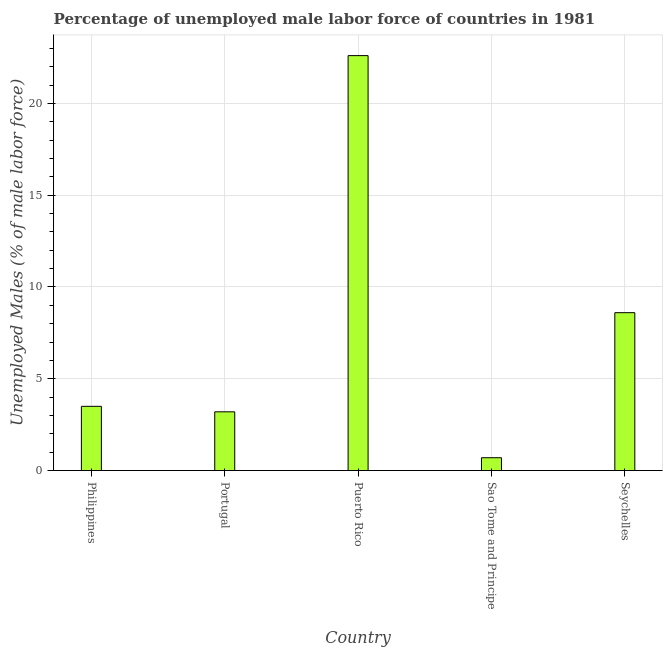Does the graph contain grids?
Keep it short and to the point. Yes. What is the title of the graph?
Offer a terse response. Percentage of unemployed male labor force of countries in 1981. What is the label or title of the X-axis?
Offer a terse response. Country. What is the label or title of the Y-axis?
Your answer should be very brief. Unemployed Males (% of male labor force). What is the total unemployed male labour force in Sao Tome and Principe?
Ensure brevity in your answer.  0.7. Across all countries, what is the maximum total unemployed male labour force?
Offer a very short reply. 22.6. Across all countries, what is the minimum total unemployed male labour force?
Provide a short and direct response. 0.7. In which country was the total unemployed male labour force maximum?
Provide a succinct answer. Puerto Rico. In which country was the total unemployed male labour force minimum?
Make the answer very short. Sao Tome and Principe. What is the sum of the total unemployed male labour force?
Offer a terse response. 38.6. What is the average total unemployed male labour force per country?
Keep it short and to the point. 7.72. What is the ratio of the total unemployed male labour force in Puerto Rico to that in Sao Tome and Principe?
Ensure brevity in your answer.  32.29. Is the difference between the total unemployed male labour force in Philippines and Sao Tome and Principe greater than the difference between any two countries?
Your response must be concise. No. Is the sum of the total unemployed male labour force in Puerto Rico and Seychelles greater than the maximum total unemployed male labour force across all countries?
Provide a succinct answer. Yes. What is the difference between the highest and the lowest total unemployed male labour force?
Make the answer very short. 21.9. Are the values on the major ticks of Y-axis written in scientific E-notation?
Offer a terse response. No. What is the Unemployed Males (% of male labor force) of Philippines?
Keep it short and to the point. 3.5. What is the Unemployed Males (% of male labor force) of Portugal?
Make the answer very short. 3.2. What is the Unemployed Males (% of male labor force) of Puerto Rico?
Give a very brief answer. 22.6. What is the Unemployed Males (% of male labor force) in Sao Tome and Principe?
Offer a terse response. 0.7. What is the Unemployed Males (% of male labor force) of Seychelles?
Ensure brevity in your answer.  8.6. What is the difference between the Unemployed Males (% of male labor force) in Philippines and Puerto Rico?
Your response must be concise. -19.1. What is the difference between the Unemployed Males (% of male labor force) in Philippines and Seychelles?
Provide a short and direct response. -5.1. What is the difference between the Unemployed Males (% of male labor force) in Portugal and Puerto Rico?
Your response must be concise. -19.4. What is the difference between the Unemployed Males (% of male labor force) in Puerto Rico and Sao Tome and Principe?
Give a very brief answer. 21.9. What is the difference between the Unemployed Males (% of male labor force) in Puerto Rico and Seychelles?
Your response must be concise. 14. What is the difference between the Unemployed Males (% of male labor force) in Sao Tome and Principe and Seychelles?
Provide a succinct answer. -7.9. What is the ratio of the Unemployed Males (% of male labor force) in Philippines to that in Portugal?
Your response must be concise. 1.09. What is the ratio of the Unemployed Males (% of male labor force) in Philippines to that in Puerto Rico?
Your answer should be very brief. 0.15. What is the ratio of the Unemployed Males (% of male labor force) in Philippines to that in Sao Tome and Principe?
Your answer should be very brief. 5. What is the ratio of the Unemployed Males (% of male labor force) in Philippines to that in Seychelles?
Make the answer very short. 0.41. What is the ratio of the Unemployed Males (% of male labor force) in Portugal to that in Puerto Rico?
Ensure brevity in your answer.  0.14. What is the ratio of the Unemployed Males (% of male labor force) in Portugal to that in Sao Tome and Principe?
Offer a very short reply. 4.57. What is the ratio of the Unemployed Males (% of male labor force) in Portugal to that in Seychelles?
Keep it short and to the point. 0.37. What is the ratio of the Unemployed Males (% of male labor force) in Puerto Rico to that in Sao Tome and Principe?
Your answer should be compact. 32.29. What is the ratio of the Unemployed Males (% of male labor force) in Puerto Rico to that in Seychelles?
Provide a short and direct response. 2.63. What is the ratio of the Unemployed Males (% of male labor force) in Sao Tome and Principe to that in Seychelles?
Provide a succinct answer. 0.08. 